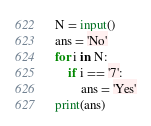Convert code to text. <code><loc_0><loc_0><loc_500><loc_500><_Python_>N = input()
ans = 'No'
for i in N:
    if i == '7':
        ans = 'Yes'
print(ans)</code> 